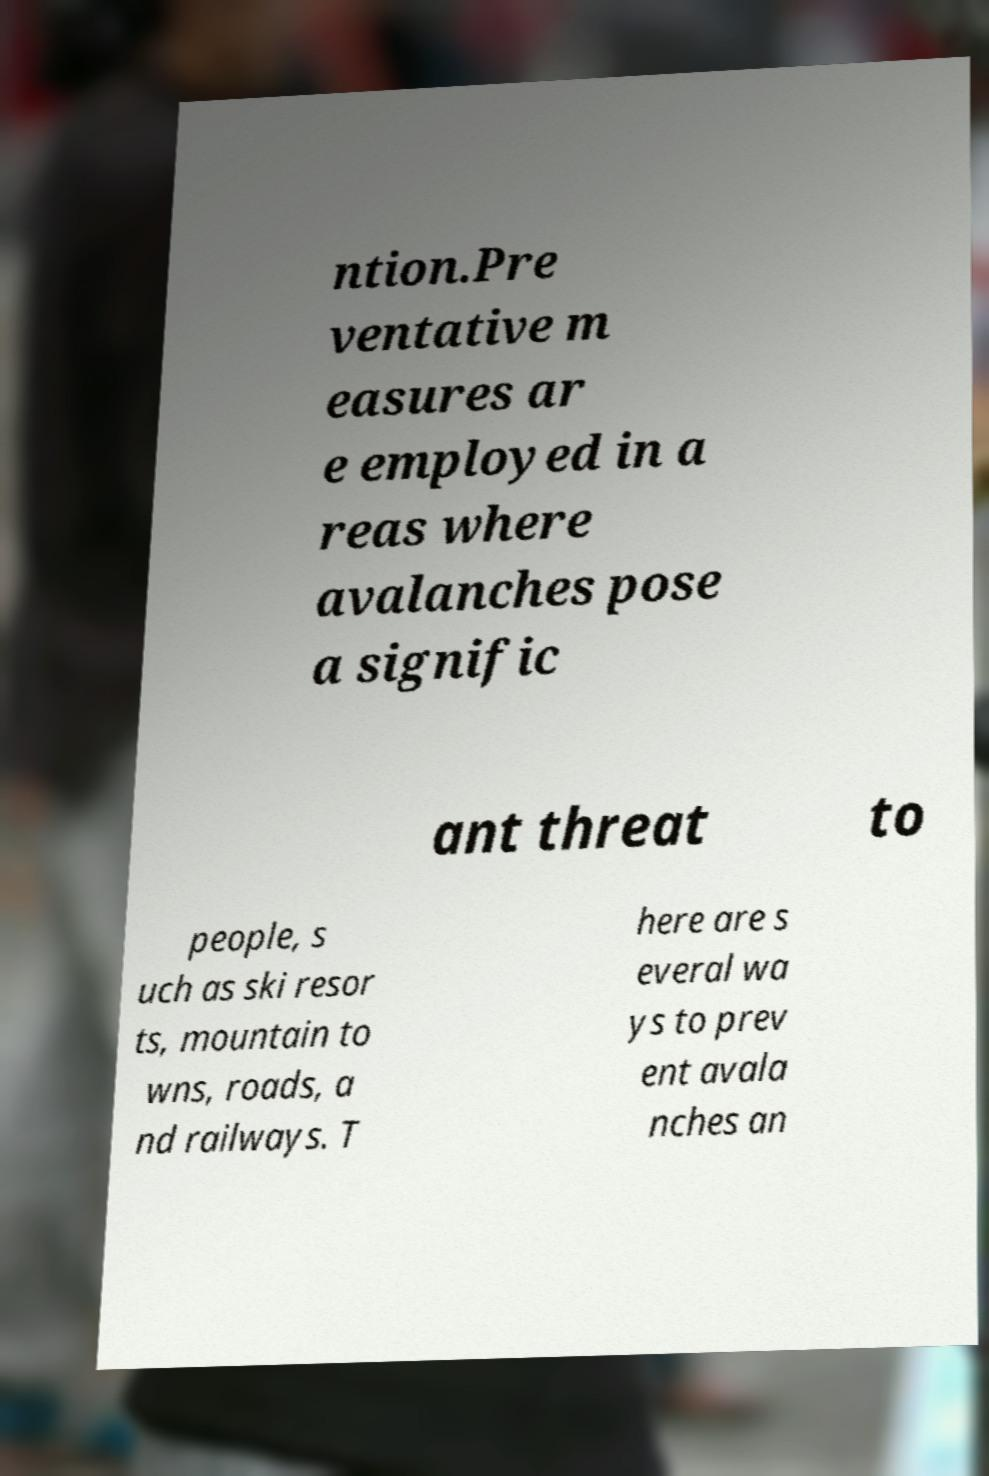Please identify and transcribe the text found in this image. ntion.Pre ventative m easures ar e employed in a reas where avalanches pose a signific ant threat to people, s uch as ski resor ts, mountain to wns, roads, a nd railways. T here are s everal wa ys to prev ent avala nches an 